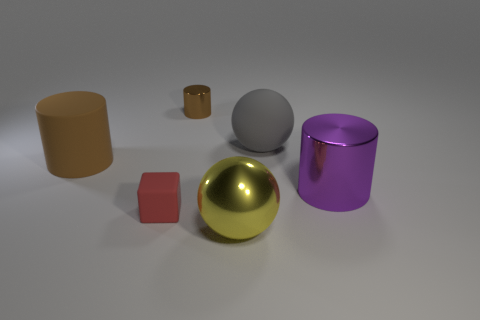Does the big rubber cylinder have the same color as the tiny cylinder?
Ensure brevity in your answer.  Yes. How many brown cylinders are left of the brown thing that is behind the big cylinder that is to the left of the yellow shiny sphere?
Provide a short and direct response. 1. The tiny cube has what color?
Offer a very short reply. Red. How many other objects are the same size as the yellow metal ball?
Give a very brief answer. 3. There is a tiny brown thing that is the same shape as the purple object; what material is it?
Ensure brevity in your answer.  Metal. There is a tiny object in front of the ball that is behind the tiny object that is on the left side of the tiny brown cylinder; what is it made of?
Ensure brevity in your answer.  Rubber. What size is the brown thing that is made of the same material as the purple cylinder?
Keep it short and to the point. Small. Are there any other things of the same color as the large matte cylinder?
Make the answer very short. Yes. There is a big matte thing that is to the left of the shiny sphere; is its color the same as the tiny thing behind the large brown object?
Offer a terse response. Yes. The big object that is on the right side of the big gray sphere is what color?
Your answer should be very brief. Purple. 